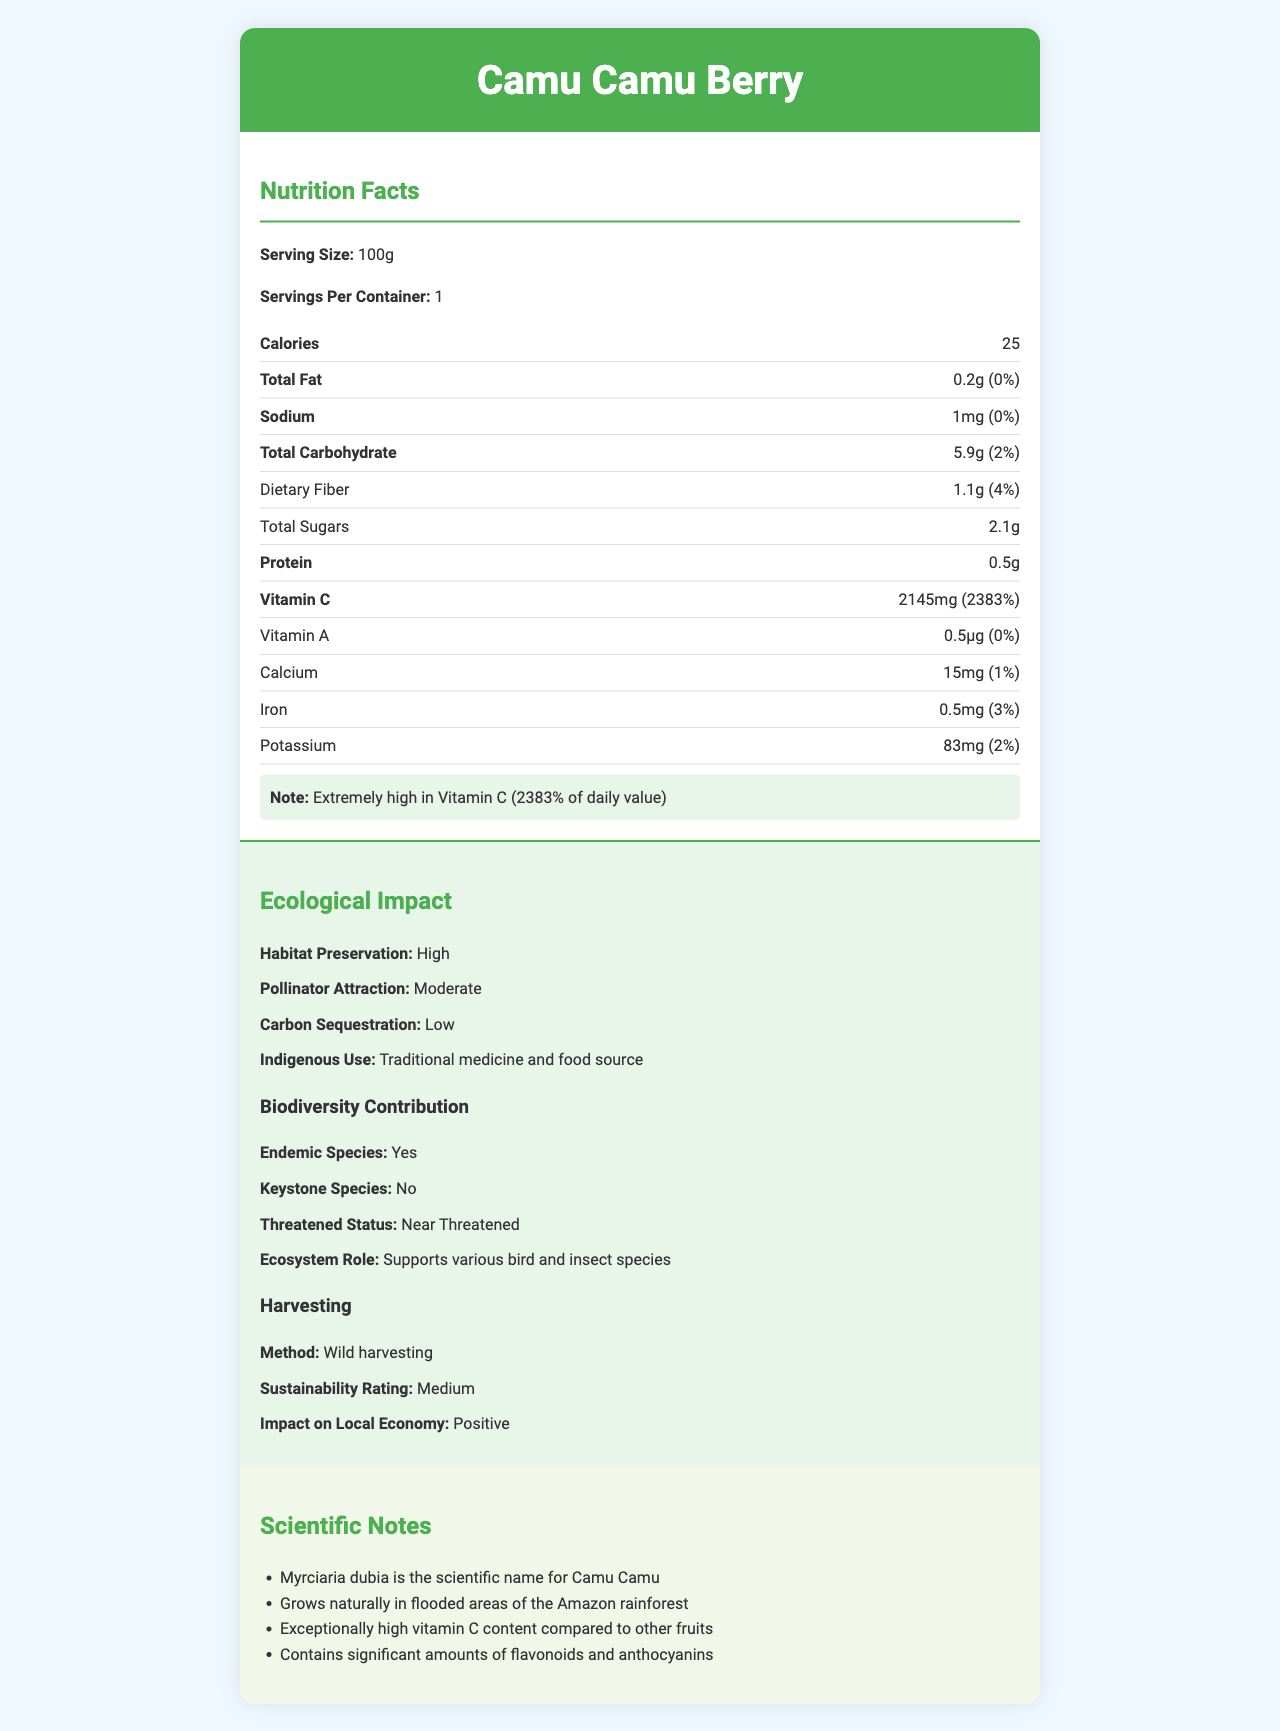What is the serving size of the Camu Camu Berry? The serving size is explicitly listed as "100g" in the document.
Answer: 100g How much vitamin C is in a serving of Camu Camu Berry? The amount of vitamin C is specified as 2145mg per serving in the document.
Answer: 2145mg What is the daily value percentage for Vitamin C in the Camu Camu Berry? The daily value percentage for Vitamin C is listed as 2383% in the document.
Answer: 2383% Does the Camu Camu Berry have any significant amount of Vitamin A? Yes/No The document lists Vitamin A at 0.5µg, which is 0% of the daily value, indicating it is not a significant amount.
Answer: No What are the ecological roles of the Camu Camu Berry? The document states that the Camu Camu Berry supports various bird and insect species in the ecosystem.
Answer: Supports various bird and insect species What is the harvesting method used for Camu Camu Berry? The document mentions that the harvesting method is wild harvesting.
Answer: Wild harvesting What is the impact of Camu Camu Berry on the local economy? The document explicitly states that the impact on the local economy is positive.
Answer: Positive Describe the entire document. The document contains detailed information regarding the nutritional profile of the Camu Camu Berry, its ecological impact, contributions to biodiversity, and the methods and effects of its harvesting.
Answer: The document provides the nutrition facts for the Camu Camu Berry, highlighting its high vitamin C content and other nutritional values. It also discusses the ecological impact, including habitat preservation, pollinator attraction, and indigenous uses. Additionally, the document details the biodiversity contribution and harvesting methods, emphasizing the economic and ecological significance of the berry. What is the sustainability rating for the Camu Camu Berry? The sustainability rating for the harvesting of Camu Camu Berry is listed as "Medium" in the document.
Answer: Medium How does Camu Camu Berry contribute to biodiversity? According to the document, the Camu Camu Berry is an endemic species and supports various bird and insect species.
Answer: Endemic species, supports various bird and insect species Which nutrient in the Camu Camu Berry has an exceptional content level compared to other fruits? A. Iron B. Vitamin A C. Vitamin C D. Calcium The document highlights that the Camu Camu Berry has an exceptionally high vitamin C content compared to other fruits.
Answer: C. Vitamin C What is the threatened status of the Camu Camu Berry? The document states that the threatened status of the Camu Camu Berry is "Near Threatened".
Answer: Near Threatened Given the data, can we determine the exact amount of flavonoids and anthocyanins in the Camu Camu Berry? The document mentions the presence of flavonoids and anthocyanins but does not provide specific quantities.
Answer: Not enough information Which statement is true about the Camu Camu Berry's contribution to the local ecosystem? I. It is a keystone species II. It attracts pollinators moderately III. It contributes to carbon sequestration highly The document specifies that the Camu Camu Berry attracts pollinators moderately and indicates that it is not a keystone species and contributes to carbon sequestration lowly.
Answer: II. It attracts pollinators moderately How does the Camu Camu Berry help in habitat preservation? The document states that the Camu Camu Berry has a high impact on habitat preservation.
Answer: High 